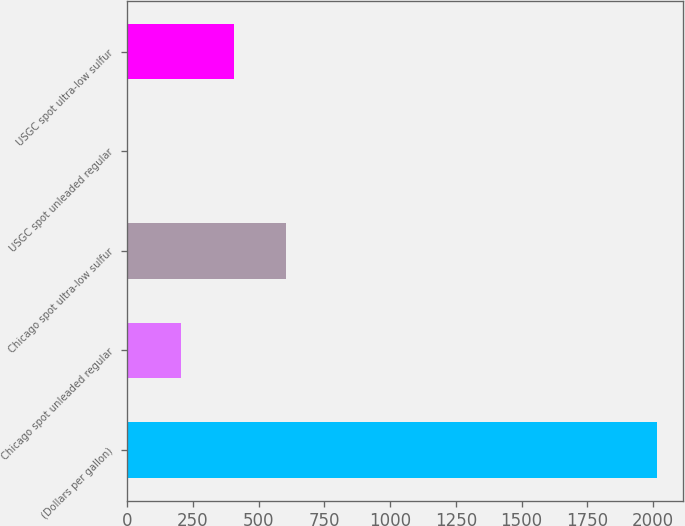Convert chart. <chart><loc_0><loc_0><loc_500><loc_500><bar_chart><fcel>(Dollars per gallon)<fcel>Chicago spot unleaded regular<fcel>Chicago spot ultra-low sulfur<fcel>USGC spot unleaded regular<fcel>USGC spot ultra-low sulfur<nl><fcel>2013<fcel>203.72<fcel>605.78<fcel>2.69<fcel>404.75<nl></chart> 